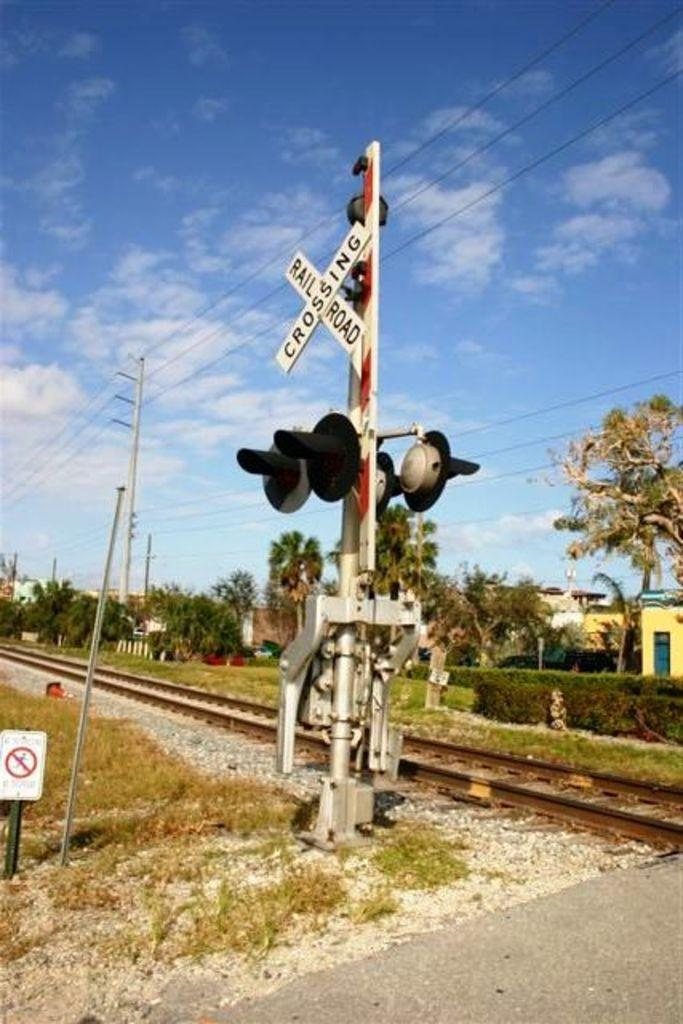<image>
Create a compact narrative representing the image presented. The words railroad crossing are on wood shaped like an x in front of the tracks. 